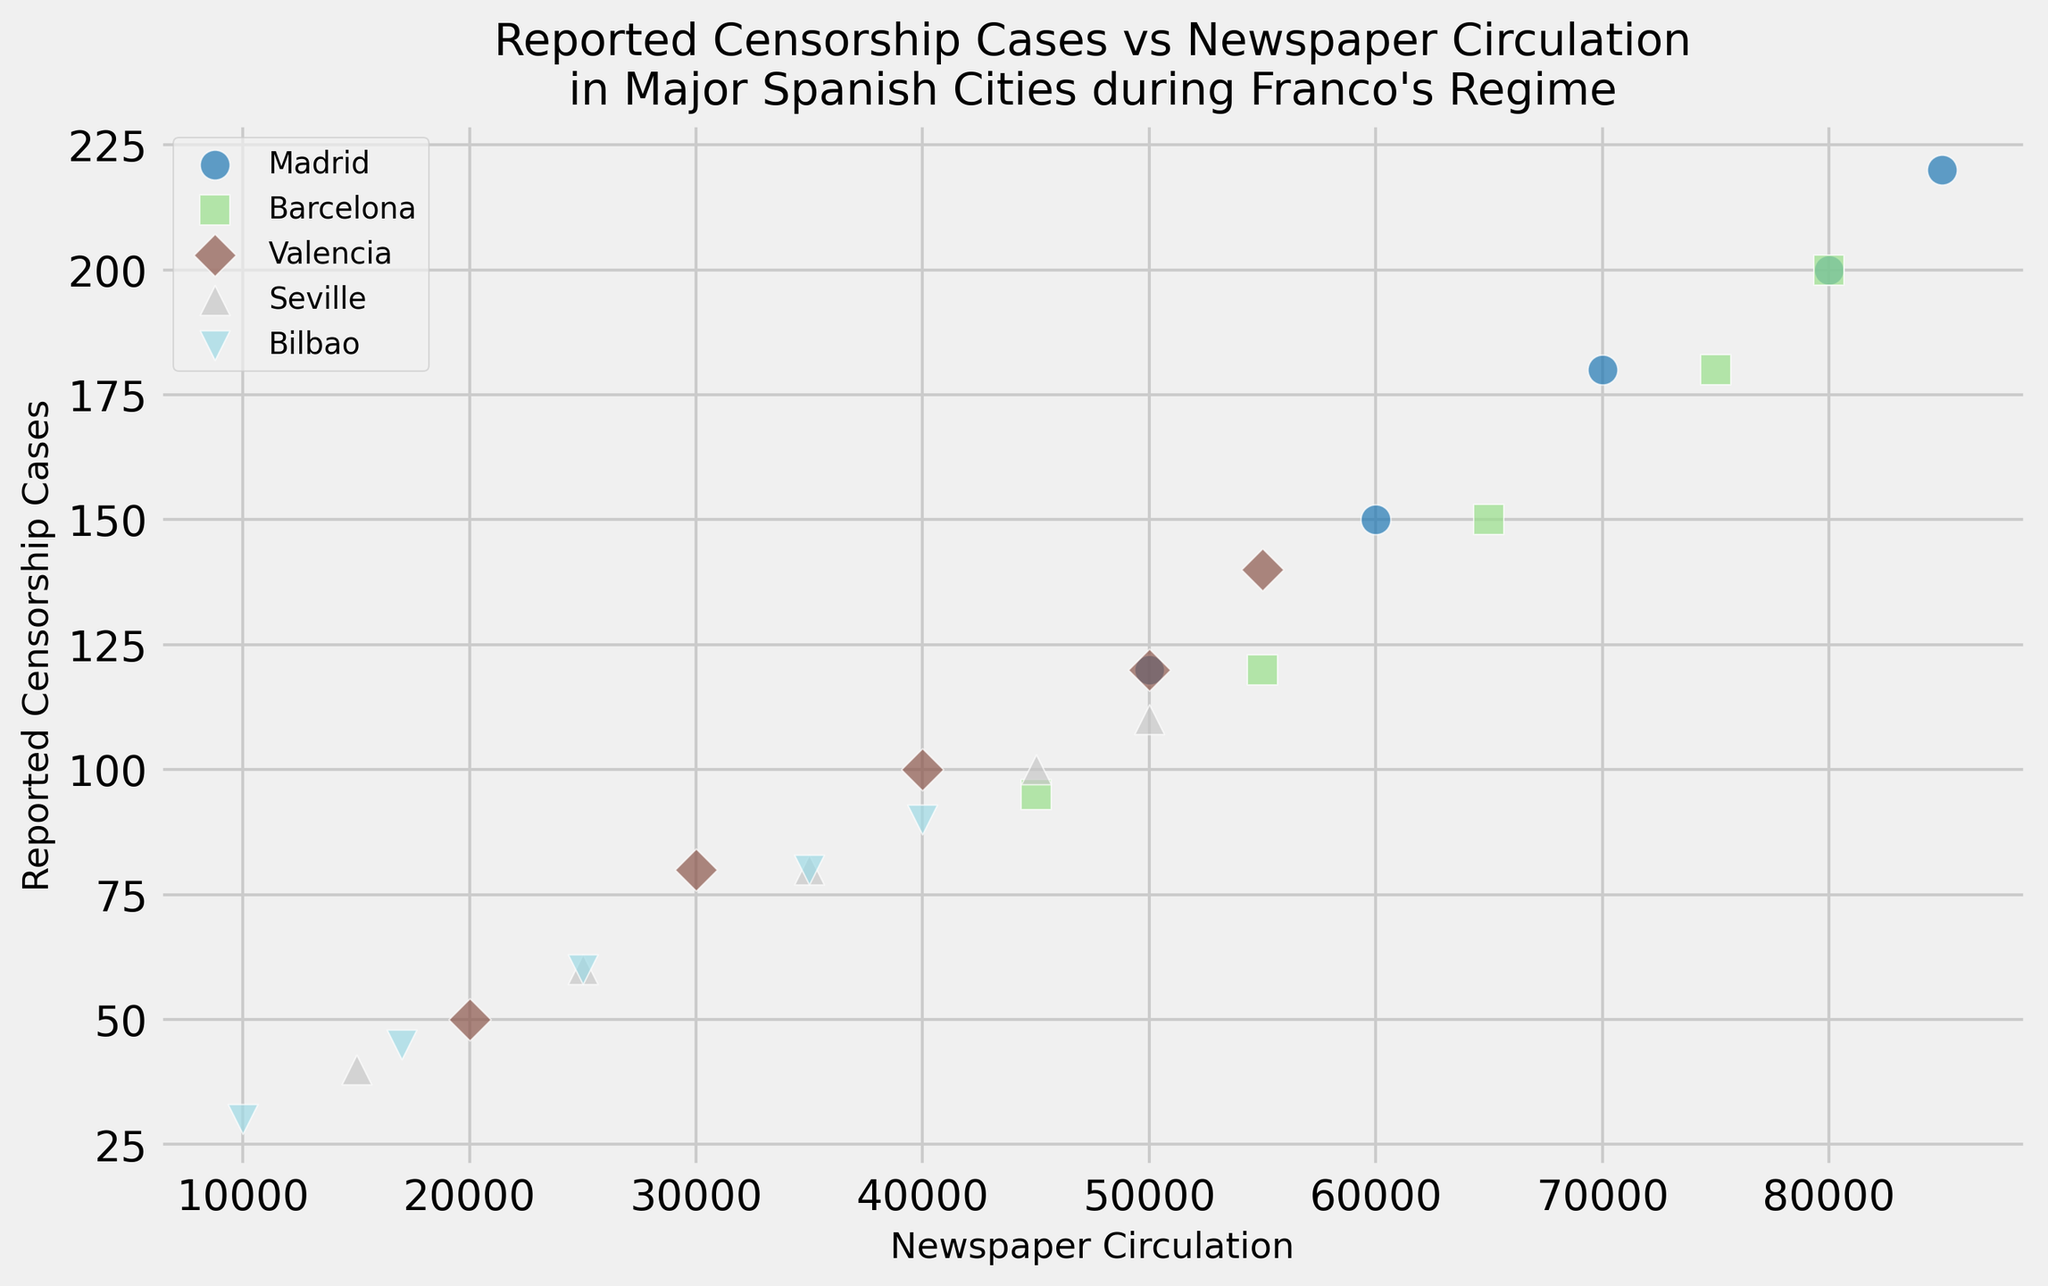Which city had the highest number of reported censorship cases in 1975? In 1975, the scatter plot shows Madrid with the highest number of reported censorship cases. You can observe this by looking at the top-most marker for 1975.
Answer: Madrid Which city experienced the greatest increase in reported censorship cases from 1940 to 1975? By comparing the positions of the markers for the years 1940 and 1975 for each city, Madrid shows the greatest increase from 120 in 1940 to 220 in 1975, an increase of 100 cases.
Answer: Madrid Between Barcelona and Valencia, which city had a higher newspaper circulation in 1960? In 1960, the scatter plot shows Barcelona with a higher newspaper circulation than Valencia. Barcelona's marker is further to the right compared to Valencia's marker.
Answer: Barcelona What is the average newspaper circulation of Seville across all years shown? To find the average, add the newspaper circulations of Seville in each year (15000, 25000, 35000, 45000, 50000) and divide by 5. The sum is 170000, so the average is 170000/5.
Answer: 34000 Which city had the fewest reported censorship cases in 1940, and how many cases were there? In 1940, the plot shows that Bilbao had the fewest reported censorship cases with 30.
Answer: Bilbao with 30 cases Compare the rate of increase in newspaper circulation for Madrid and Seville from 1950 to 1970. Which city had a higher rate? From 1950 to 1970, Madrid's newspaper circulation increased from 60000 to 80000, an increase of 20000. Seville's circulation increased from 25000 to 45000, an increase of 20000. Both cities had the same rate of increase.
Answer: Same rate Which city had the highest ratio of reported censorship cases to newspaper circulation in 1975? To determine the ratio, divide the number of reported cases by the newspaper circulation for each city in 1975, and compare. Madrid: 220/85000, Barcelona: 200/80000, Valencia: 140/55000, Seville: 110/50000, Bilbao: 90/40000. Bilbao has the highest ratio.
Answer: Bilbao What color marker represents Barcelona in the plot? Each city has a distinct color, and Barcelona is consistently marked with a specific color throughout the plot. By identifying the color in the legend, you can see that Barcelona is marked with a green color.
Answer: Green Which year shows the smallest difference in reported censorship cases between Barcelona and Valencia? Look at the vertical positions of the markers for Barcelona and Valencia across the years and compare their differences. In 1960, the difference is the smallest (150 - 100 = 50).
Answer: 1960 